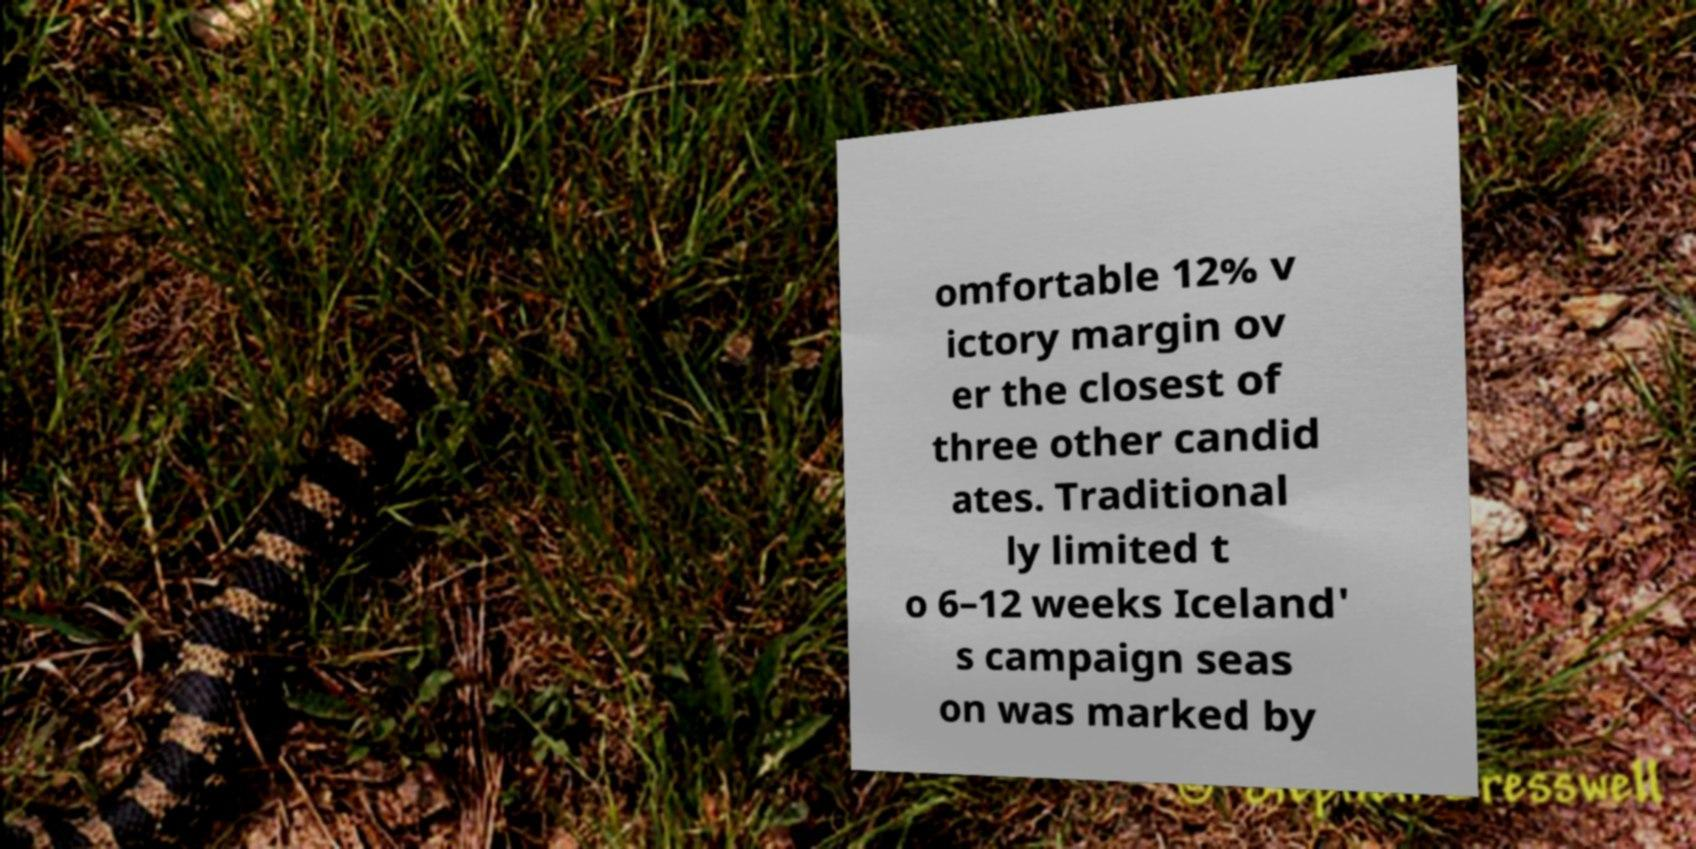For documentation purposes, I need the text within this image transcribed. Could you provide that? omfortable 12% v ictory margin ov er the closest of three other candid ates. Traditional ly limited t o 6–12 weeks Iceland' s campaign seas on was marked by 